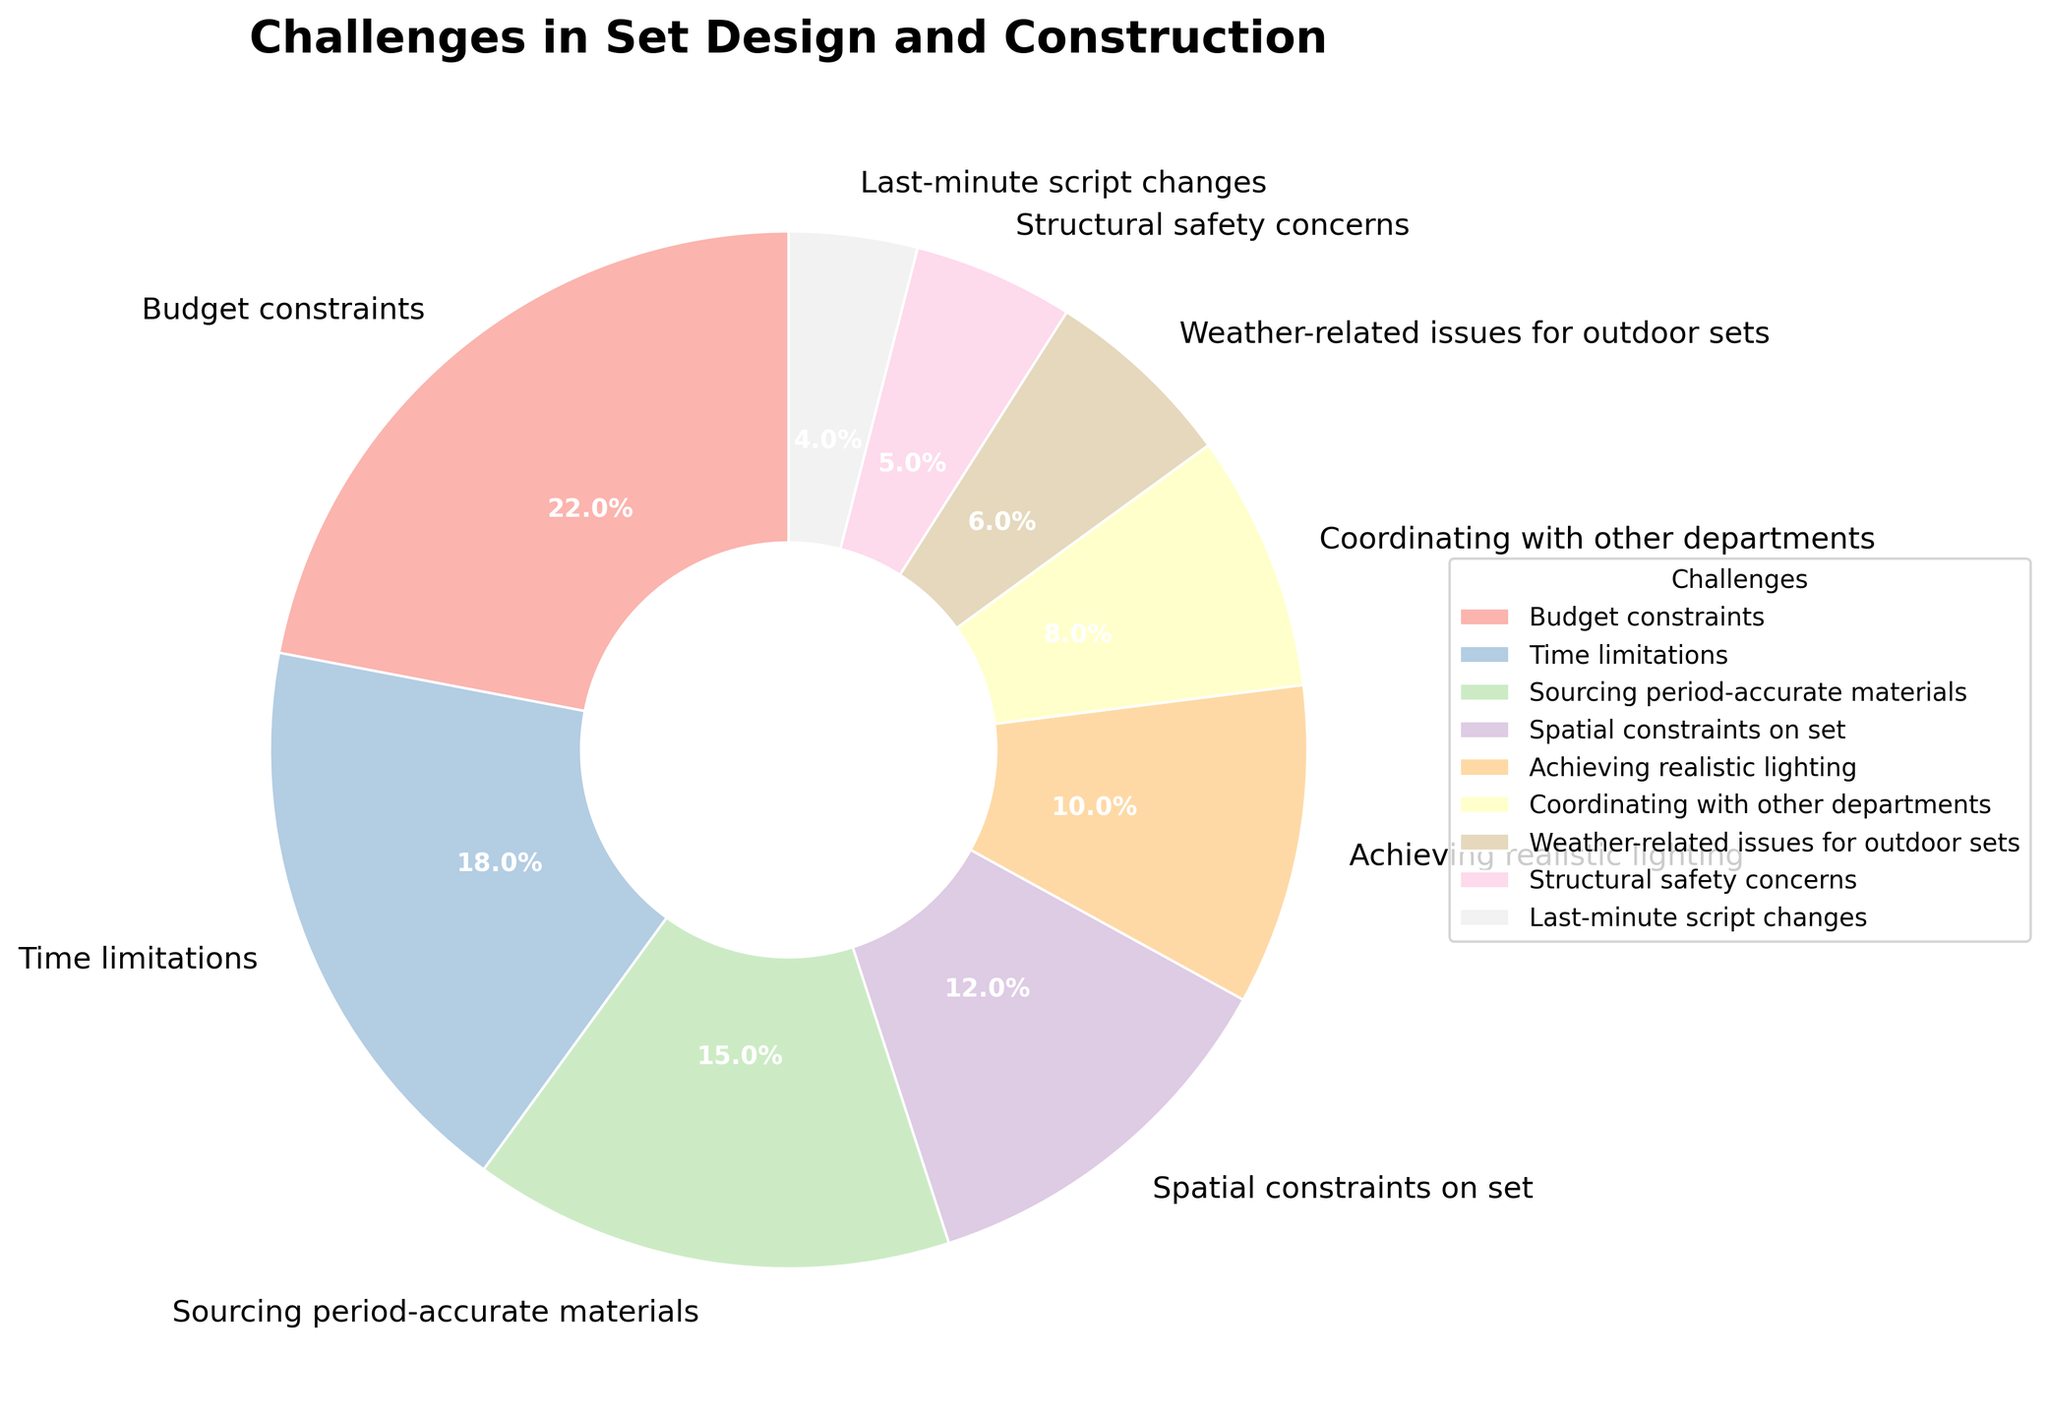What is the largest challenge in set design based on the pie chart? Look at the segment with the largest percentage in the pie chart; "Budget constraints" have the highest percentage at 22%.
Answer: Budget constraints Which challenge has a percentage closest to 10%? Check the segments around the 10% mark in the pie chart; "Achieving realistic lighting" has a percentage of 10%.
Answer: Achieving realistic lighting What is the combined percentage for "Sourcing period-accurate materials" and "Coordinating with other departments"? Add the percentages of these two challenges: 15% (Sourcing period-accurate materials) + 8% (Coordinating with other departments) = 23%.
Answer: 23% Which challenges are more significant than "Weather-related issues for outdoor sets"? Compare the segments with percentages higher than 6%; these are "Budget constraints," "Time limitations," "Sourcing period-accurate materials," "Spatial constraints on set," "Achieving realistic lighting," and "Coordinating with other departments".
Answer: Budget constraints, Time limitations, Sourcing period-accurate materials, Spatial constraints on set, Achieving realistic lighting, Coordinating with other departments Is "Structural safety concerns" a bigger or smaller challenge compared to "Last-minute script changes"? Compare the percentages: "Structural safety concerns" is at 5%, while "Last-minute script changes" is at 4%. Thus, "Structural safety concerns" is a bigger challenge.
Answer: Bigger What is the total percentage for challenges related to physical constraints (Spatial constraints on set and Structural safety concerns)? Add their percentages: 12% (Spatial constraints on set) + 5% (Structural safety concerns) = 17%.
Answer: 17% Which challenge had nearly half the significance of "Budget constraints"? Find the challenge with the percentage closest to half of 22%, which is 11%; "Achieving realistic lighting" at 10% is the closest.
Answer: Achieving realistic lighting What percentage of the challenges are related to coordination (Coordinating with other departments and Last-minute script changes)? Add the percentages: 8% (Coordinating with other departments) + 4% (Last-minute script changes) = 12%.
Answer: 12% Among the challenges listed, which one is the smallest on the pie chart? Identify the segment with the lowest percentage; "Last-minute script changes" has the lowest at 4%.
Answer: Last-minute script changes How much more significant is "Time limitations" compared to "Weather-related issues for outdoor sets"? Subtract the percentage of "Weather-related issues for outdoor sets" from "Time limitations": 18% - 6% = 12%.
Answer: 12% 